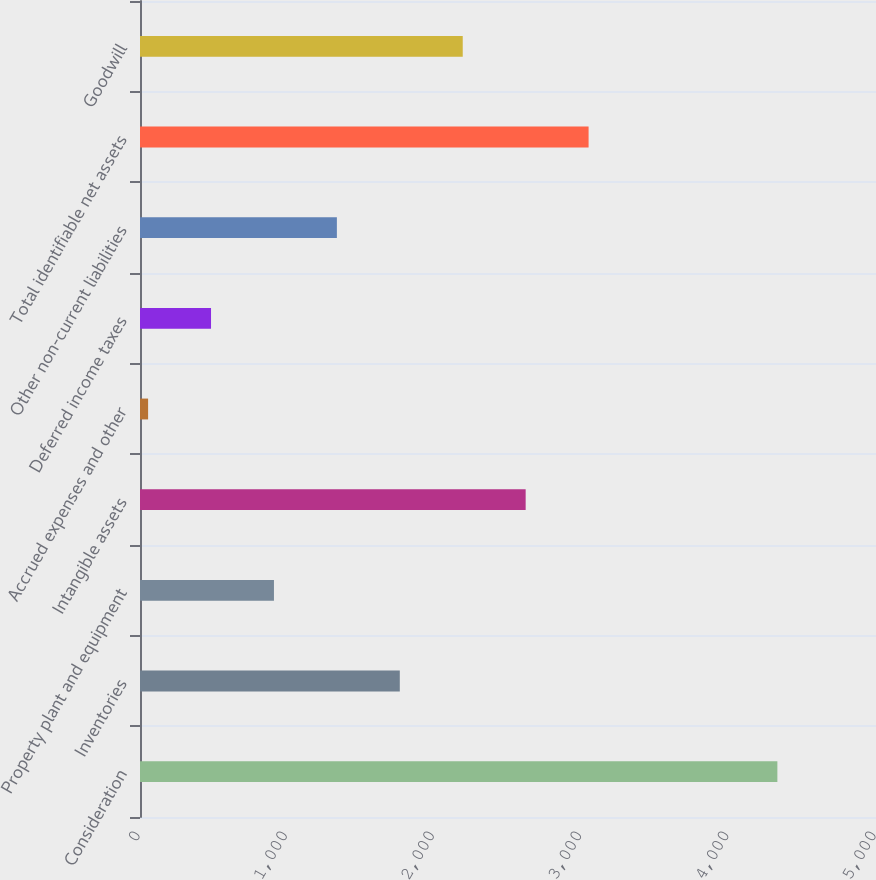Convert chart to OTSL. <chart><loc_0><loc_0><loc_500><loc_500><bar_chart><fcel>Consideration<fcel>Inventories<fcel>Property plant and equipment<fcel>Intangible assets<fcel>Accrued expenses and other<fcel>Deferred income taxes<fcel>Other non-current liabilities<fcel>Total identifiable net assets<fcel>Goodwill<nl><fcel>4330<fcel>1765<fcel>910<fcel>2620<fcel>55<fcel>482.5<fcel>1337.5<fcel>3047.5<fcel>2192.5<nl></chart> 